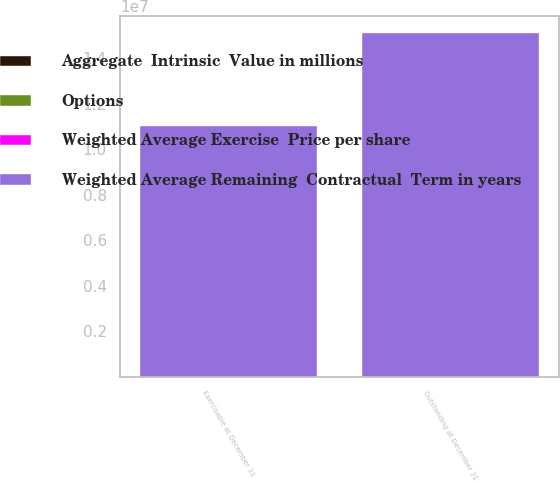<chart> <loc_0><loc_0><loc_500><loc_500><stacked_bar_chart><ecel><fcel>Outstanding at December 31<fcel>Exercisable at December 31<nl><fcel>Weighted Average Remaining  Contractual  Term in years<fcel>1.50889e+07<fcel>1.09993e+07<nl><fcel>Options<fcel>43.49<fcel>44.54<nl><fcel>Aggregate  Intrinsic  Value in millions<fcel>5.4<fcel>4.3<nl><fcel>Weighted Average Exercise  Price per share<fcel>40<fcel>26<nl></chart> 